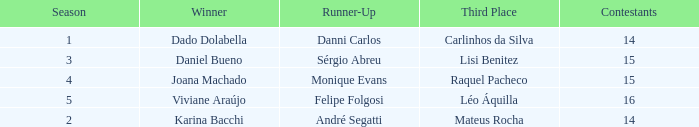In what season was the winner Dado Dolabella? 1.0. I'm looking to parse the entire table for insights. Could you assist me with that? {'header': ['Season', 'Winner', 'Runner-Up', 'Third Place', 'Contestants'], 'rows': [['1', 'Dado Dolabella', 'Danni Carlos', 'Carlinhos da Silva', '14'], ['3', 'Daniel Bueno', 'Sérgio Abreu', 'Lisi Benitez', '15'], ['4', 'Joana Machado', 'Monique Evans', 'Raquel Pacheco', '15'], ['5', 'Viviane Araújo', 'Felipe Folgosi', 'Léo Áquilla', '16'], ['2', 'Karina Bacchi', 'André Segatti', 'Mateus Rocha', '14']]} 